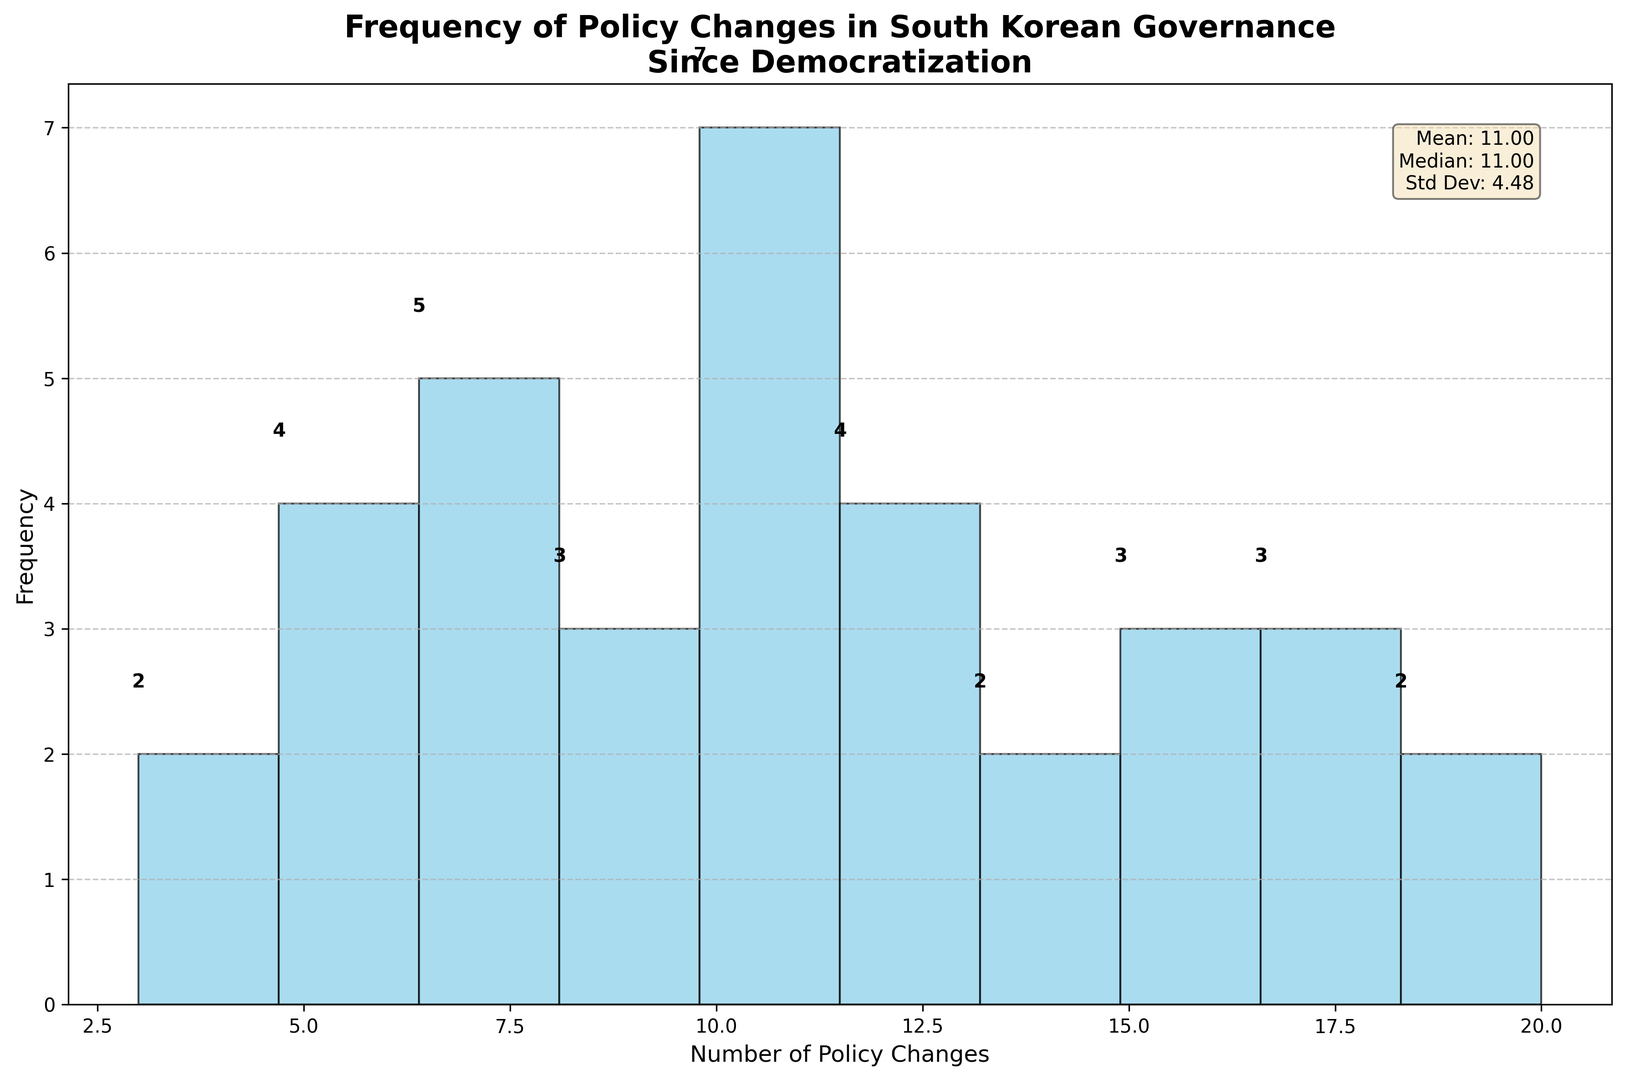What is the mean number of policy changes? The mean number of policy changes is calculated as the sum of all policy changes divided by the number of years. According to the summary statistics in the text box in the figure, the mean is provided directly.
Answer: 11.26 What is the most frequent range of policy changes? By examining the histogram, the range with the highest bar represents the most frequent range of policy changes. The height of the bars indicates the frequency.
Answer: 8-10 How many years had between 10 and 12 policy changes? We need to look at the bars corresponding to the 10-12 range and count the frequencies. According to the histogram, count the heights of bars between 10 and 12 policy changes.
Answer: 8 What is the median number of policy changes? The median value is included in the summary statistics text box.
Answer: 11 Compare the frequency of years with policy changes in the range of 14-16 to those in the range of 17-20. Count the bars' heights in both ranges and compare the numbers. The range 14-16 has one bar with a height of 5, and the range 17-20 has one bar with a height of 4.
Answer: 5 vs. 4 What range has the smallest frequency of policy changes? Identify the range with the shortest bar, indicating the smallest frequency.
Answer: 0-2 and 3-5 (tie) What is the frequency of years with more than 10 policy changes? Add up the frequencies of the bars corresponding to values greater than 10. According to the histogram, this includes all bins from 11 and above.
Answer: 15 